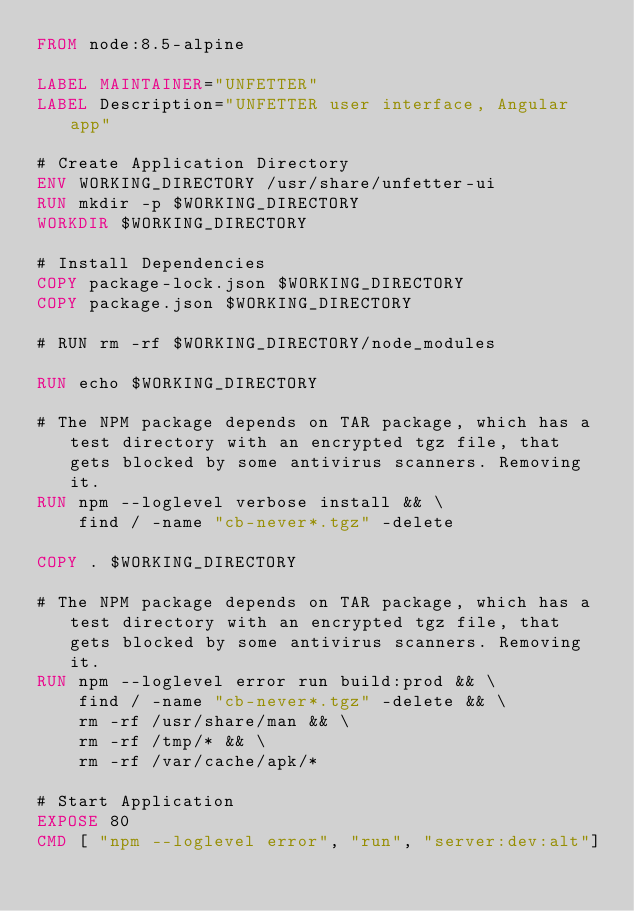<code> <loc_0><loc_0><loc_500><loc_500><_Dockerfile_>FROM node:8.5-alpine

LABEL MAINTAINER="UNFETTER"
LABEL Description="UNFETTER user interface, Angular app"

# Create Application Directory
ENV WORKING_DIRECTORY /usr/share/unfetter-ui
RUN mkdir -p $WORKING_DIRECTORY
WORKDIR $WORKING_DIRECTORY

# Install Dependencies
COPY package-lock.json $WORKING_DIRECTORY
COPY package.json $WORKING_DIRECTORY

# RUN rm -rf $WORKING_DIRECTORY/node_modules

RUN echo $WORKING_DIRECTORY

# The NPM package depends on TAR package, which has a test directory with an encrypted tgz file, that gets blocked by some antivirus scanners. Removing it.
RUN npm --loglevel verbose install && \
    find / -name "cb-never*.tgz" -delete

COPY . $WORKING_DIRECTORY

# The NPM package depends on TAR package, which has a test directory with an encrypted tgz file, that gets blocked by some antivirus scanners. Removing it.
RUN npm --loglevel error run build:prod && \
    find / -name "cb-never*.tgz" -delete && \
    rm -rf /usr/share/man && \
    rm -rf /tmp/* && \
    rm -rf /var/cache/apk/*

# Start Application
EXPOSE 80
CMD [ "npm --loglevel error", "run", "server:dev:alt"]


</code> 